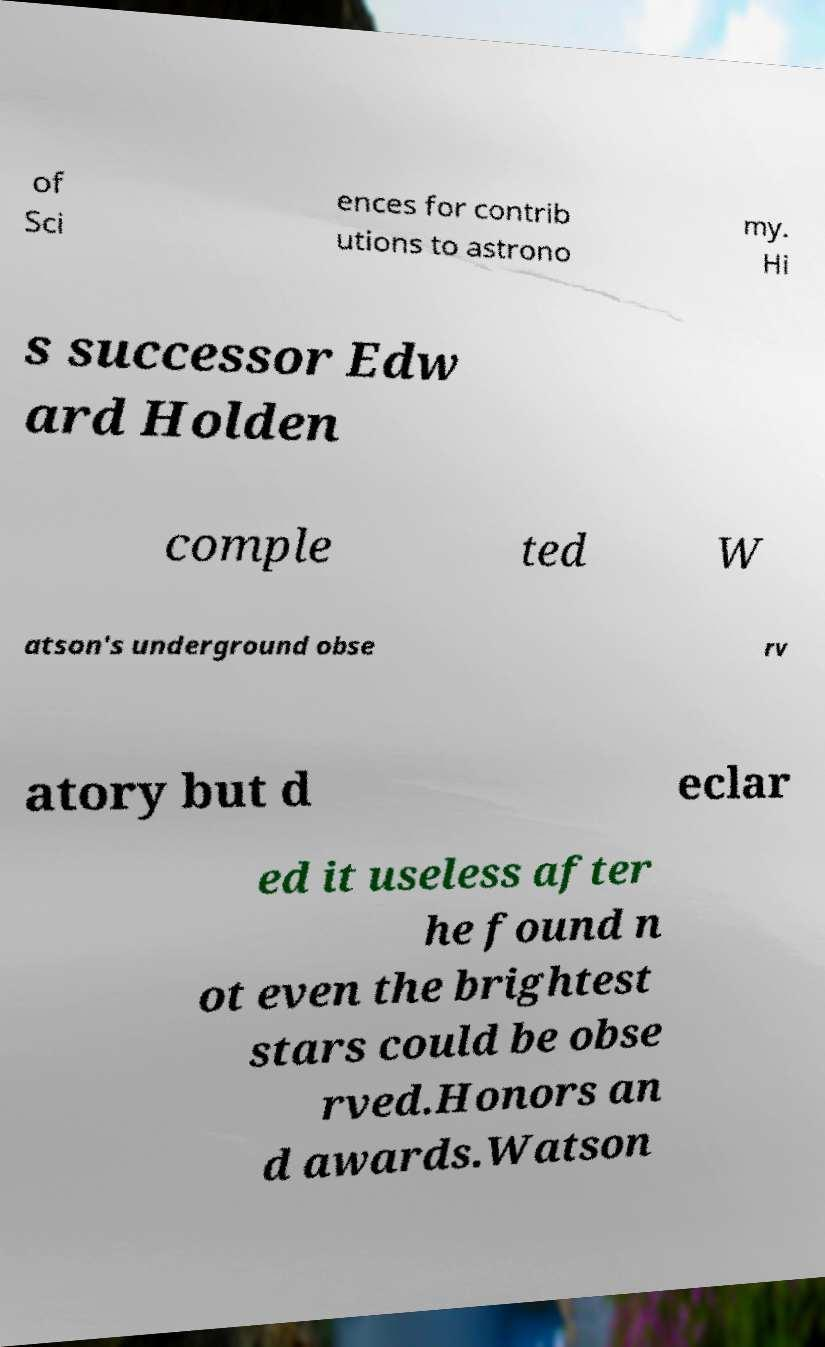Please read and relay the text visible in this image. What does it say? of Sci ences for contrib utions to astrono my. Hi s successor Edw ard Holden comple ted W atson's underground obse rv atory but d eclar ed it useless after he found n ot even the brightest stars could be obse rved.Honors an d awards.Watson 